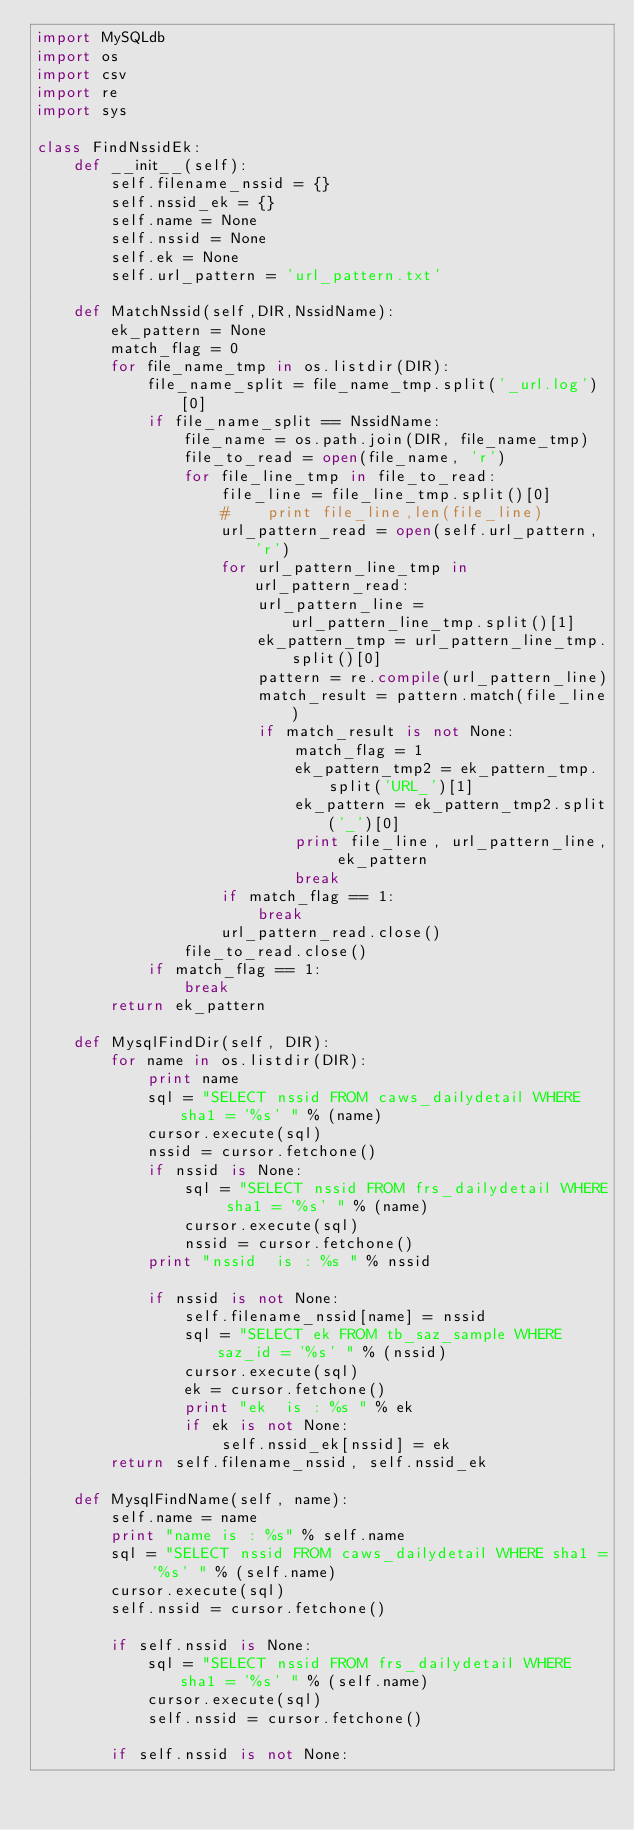<code> <loc_0><loc_0><loc_500><loc_500><_Python_>import MySQLdb
import os
import csv
import re
import sys

class FindNssidEk:
    def __init__(self):
        self.filename_nssid = {}
        self.nssid_ek = {}
        self.name = None
        self.nssid = None
        self.ek = None
        self.url_pattern = 'url_pattern.txt'

    def MatchNssid(self,DIR,NssidName):
        ek_pattern = None
        match_flag = 0
        for file_name_tmp in os.listdir(DIR):
            file_name_split = file_name_tmp.split('_url.log')[0]
            if file_name_split == NssidName:
                file_name = os.path.join(DIR, file_name_tmp)
                file_to_read = open(file_name, 'r')
                for file_line_tmp in file_to_read:
                    file_line = file_line_tmp.split()[0]
                    #    print file_line,len(file_line)
                    url_pattern_read = open(self.url_pattern, 'r')
                    for url_pattern_line_tmp in url_pattern_read:
                        url_pattern_line = url_pattern_line_tmp.split()[1]
                        ek_pattern_tmp = url_pattern_line_tmp.split()[0]
                        pattern = re.compile(url_pattern_line)
                        match_result = pattern.match(file_line)
                        if match_result is not None:
                            match_flag = 1
                            ek_pattern_tmp2 = ek_pattern_tmp.split('URL_')[1]
                            ek_pattern = ek_pattern_tmp2.split('_')[0]
                            print file_line, url_pattern_line, ek_pattern
                            break
                    if match_flag == 1:
                        break
                    url_pattern_read.close()
                file_to_read.close()
            if match_flag == 1:
                break
        return ek_pattern

    def MysqlFindDir(self, DIR):
        for name in os.listdir(DIR):
            print name
            sql = "SELECT nssid FROM caws_dailydetail WHERE sha1 = '%s' " % (name)
            cursor.execute(sql)
            nssid = cursor.fetchone()
            if nssid is None:
                sql = "SELECT nssid FROM frs_dailydetail WHERE sha1 = '%s' " % (name)
                cursor.execute(sql)
                nssid = cursor.fetchone()
            print "nssid  is : %s " % nssid

            if nssid is not None:
                self.filename_nssid[name] = nssid
                sql = "SELECT ek FROM tb_saz_sample WHERE saz_id = '%s' " % (nssid)
                cursor.execute(sql)
                ek = cursor.fetchone()
                print "ek  is : %s " % ek
                if ek is not None:
                    self.nssid_ek[nssid] = ek
        return self.filename_nssid, self.nssid_ek

    def MysqlFindName(self, name):
        self.name = name
        print "name is : %s" % self.name
        sql = "SELECT nssid FROM caws_dailydetail WHERE sha1 = '%s' " % (self.name)
        cursor.execute(sql)
        self.nssid = cursor.fetchone()

        if self.nssid is None:
            sql = "SELECT nssid FROM frs_dailydetail WHERE sha1 = '%s' " % (self.name)
            cursor.execute(sql)
            self.nssid = cursor.fetchone()

        if self.nssid is not None:</code> 